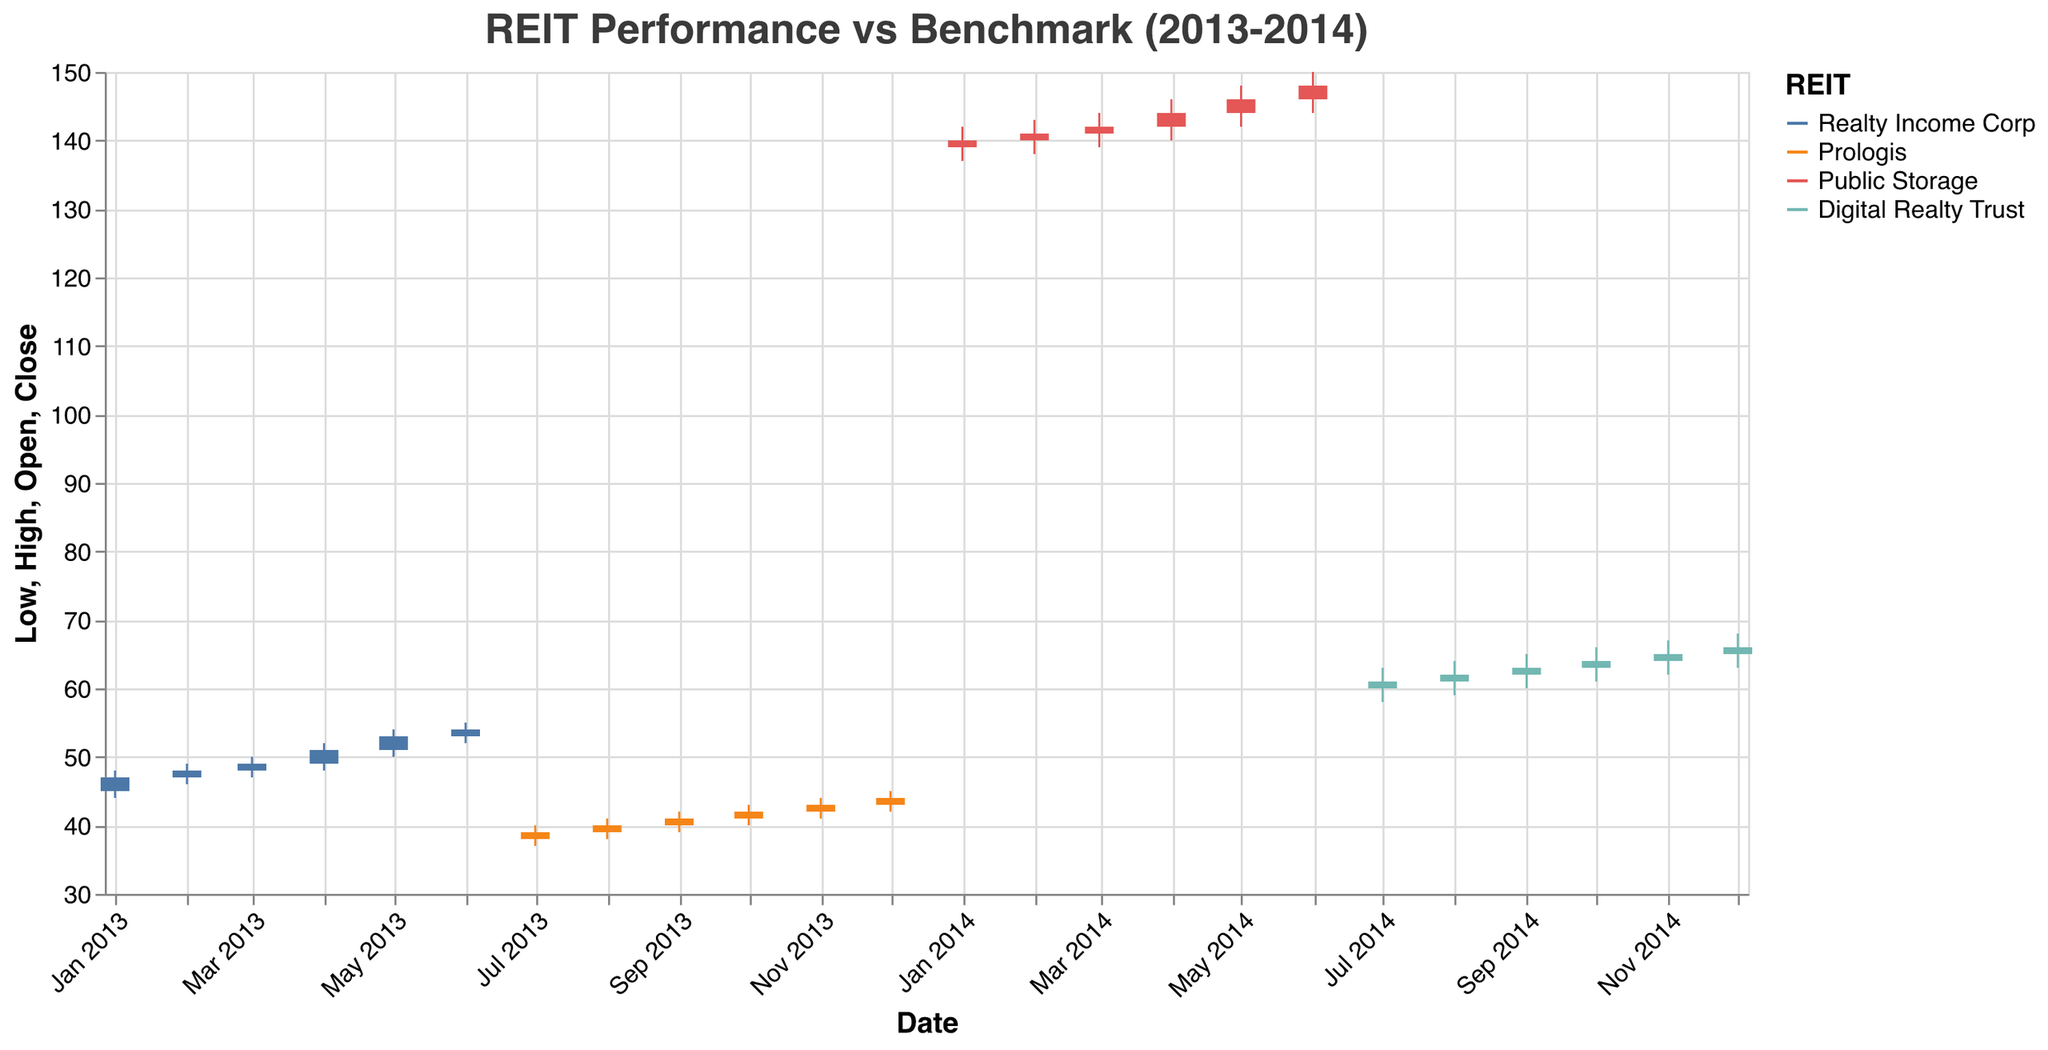What is the title of the figure? The title of the figure is displayed at the top and it describes the general context of the data presented on the plot.
Answer: REIT Performance vs Benchmark (2013-2014) Which REIT shows the highest closing value in the dataset? By examining the highest closing values in the candlestick plots, we find that Public Storage (PSA) reaches a closing value of 148 in June 2014.
Answer: Public Storage (PSA) What was the closing value of Realty Income Corp in April 2013? Find the candlestick corresponding to Realty Income Corp for April 2013 which shows a closing value at the top of the candlestick's body.
Answer: 51 Which month shows the highest closing value for Prologis? To determine this, look through all the candlesticks corresponding to Prologis by identifying the months and REITs and find the one with the highest closing value.
Answer: December 2013 How many REITs are represented in the plot? The plot legend lists the REITs with distinct colors. Count the names listed there.
Answer: 4 Did Digital Realty Trust's closing value increase or decrease from July 2014 to August 2014? Compare the closing values of Digital Realty Trust for July 2014 and August 2014. July ends at 61, August ends at 62, showing an increase.
Answer: Increase What is the difference between the highest and lowest closing values of Public Storage? Identify the highest (148 in June 2014) and the lowest (140 in January 2014) closing values for Public Storage and subtract the lowest from the highest.
Answer: 8 Which REIT had the highest monthly high value in the dataset, and what was it? Scan for the highest point in all candlesticks and identify the corresponding REIT. The highest monthly high value is for Public Storage in June 2014 at 150.
Answer: Public Storage, 150 How does the closing value of the benchmark indices in December 2013 compare to January 2014? Examine the closing values of benchmark indices for both months. It was 1620 in December 2013 and 1635 in January 2014, indicating an increase.
Answer: Increased What color represents Realty Income Corp on the plot? In the legend, find the color associated with Realty Income Corp.
Answer: Blue 